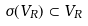Convert formula to latex. <formula><loc_0><loc_0><loc_500><loc_500>\sigma ( V _ { R } ) \subset V _ { R }</formula> 